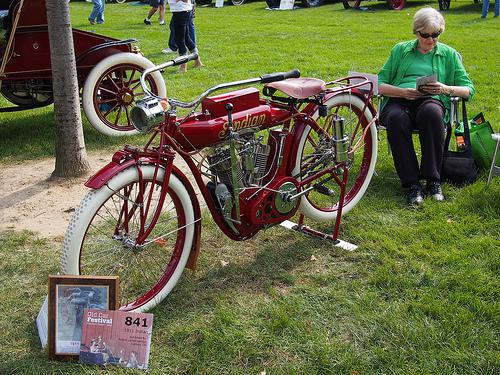Question: what color is the bike in the photo?
Choices:
A. Blue and white.
B. Black and grey.
C. Silver and black.
D. Red and white.
Answer with the letter. Answer: D Question: what color shirt is the woman wearing?
Choices:
A. Red.
B. Green.
C. Black.
D. White.
Answer with the letter. Answer: B Question: what number is on the first book that is on the ground?
Choices:
A. 840.
B. 841.
C. 838.
D. 839.
Answer with the letter. Answer: B 